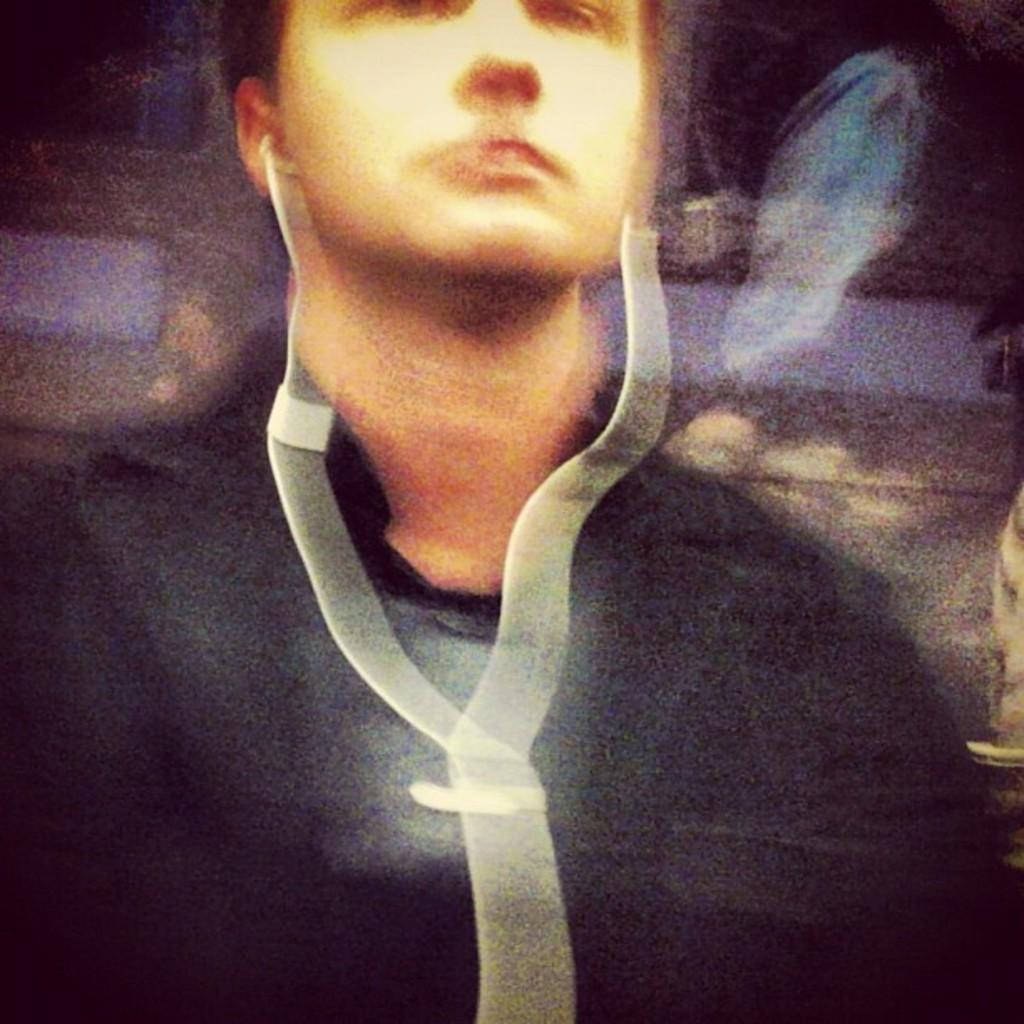What is the main subject of the image? There is a man in the image. Can you describe the man's attire? The man is wearing a black dress. What can be seen in the man's ears? The man has headphones in his ears. What type of religious symbol can be seen on the man's forehead in the image? There is no religious symbol visible on the man's forehead in the image. What is the man using to collect water from the waves in the image? There are no waves or pails present in the image; it features a man wearing a black dress and headphones. 